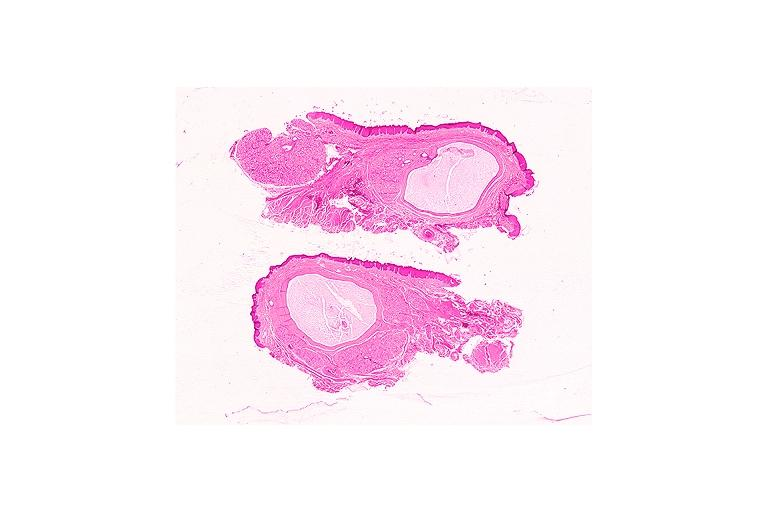s oral present?
Answer the question using a single word or phrase. Yes 